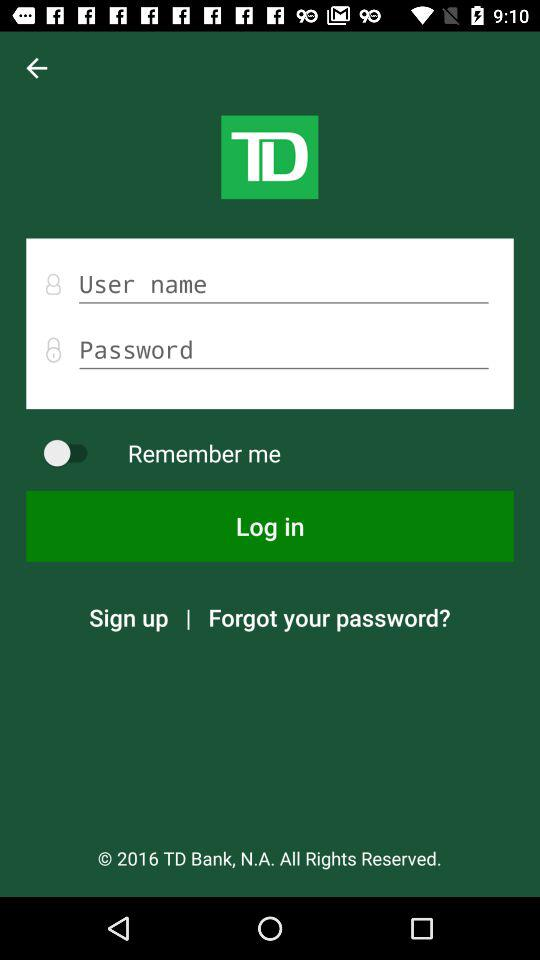What is the status of "Remember me"? The status is "off". 